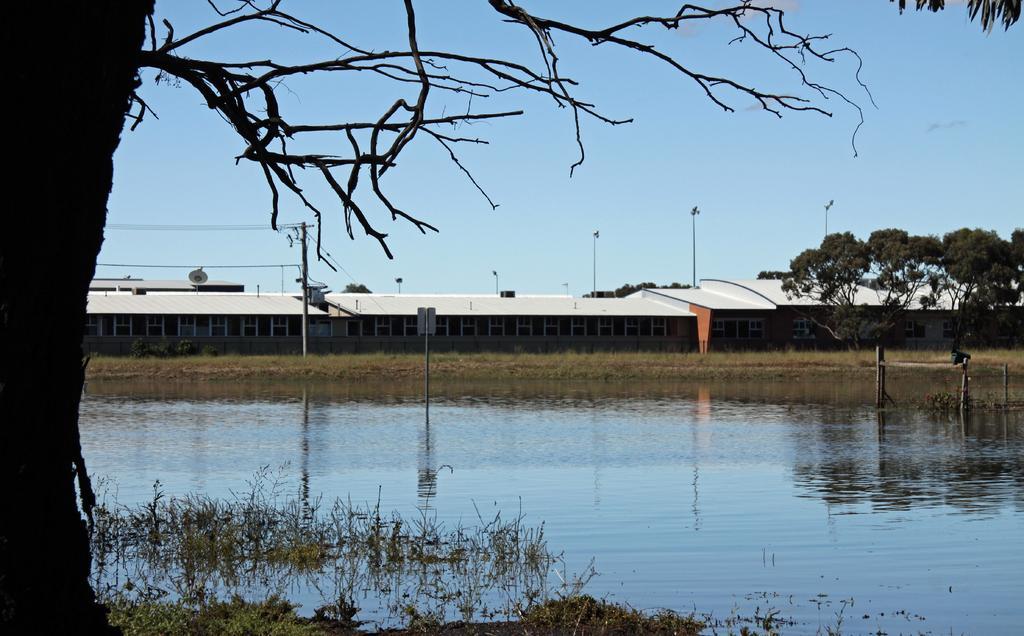Could you give a brief overview of what you see in this image? In this image we can see shelters, trees, poles and other objects. On the left side of the image there is a tree. At the bottom of the image there are water and grass. On the water we can see some reflections. At the top of the image there is the sky. 